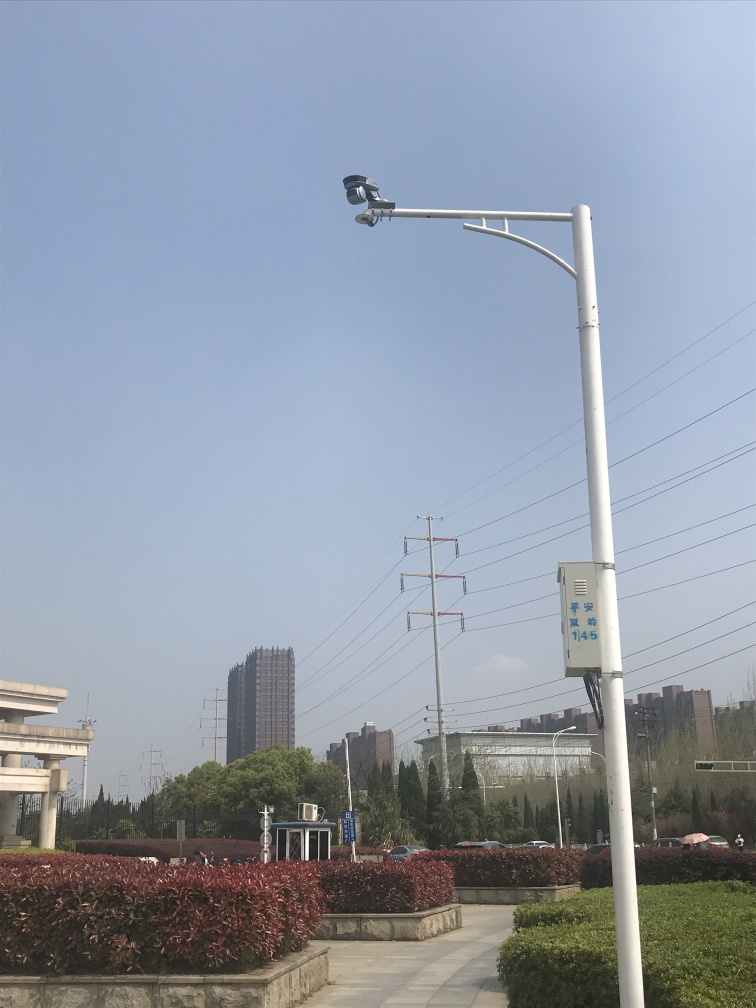What is the significance of the surveillance camera? Surveillance cameras like the one in this image are typically installed for security purposes, monitoring the surroundings and providing a measure of safety. They can deter criminal activity and are useful for collecting evidence if crimes do occur.  Does the environment appear to be well-maintained? Yes, the environment looks well-maintained. The greenery is neatly trimmed, and the area is clean with no visible litter. This suggests regular upkeep and attention to the aesthetics and functionality of the space. 